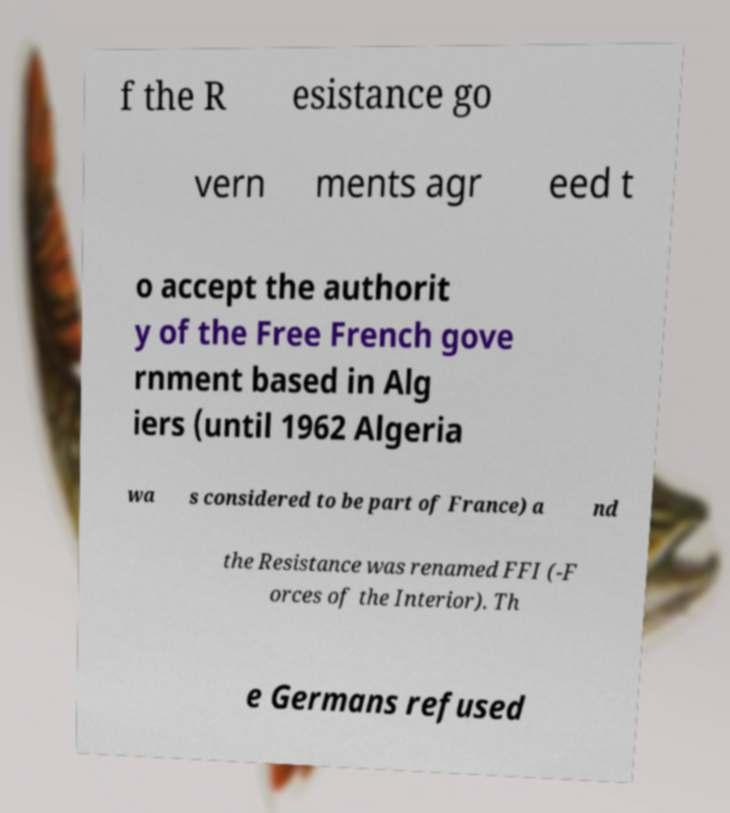Can you accurately transcribe the text from the provided image for me? f the R esistance go vern ments agr eed t o accept the authorit y of the Free French gove rnment based in Alg iers (until 1962 Algeria wa s considered to be part of France) a nd the Resistance was renamed FFI (-F orces of the Interior). Th e Germans refused 